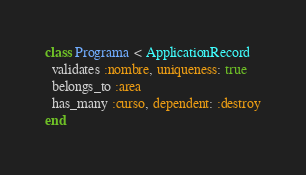Convert code to text. <code><loc_0><loc_0><loc_500><loc_500><_Ruby_>class Programa < ApplicationRecord
  validates :nombre, uniqueness: true
  belongs_to :area
  has_many :curso, dependent: :destroy
end
</code> 